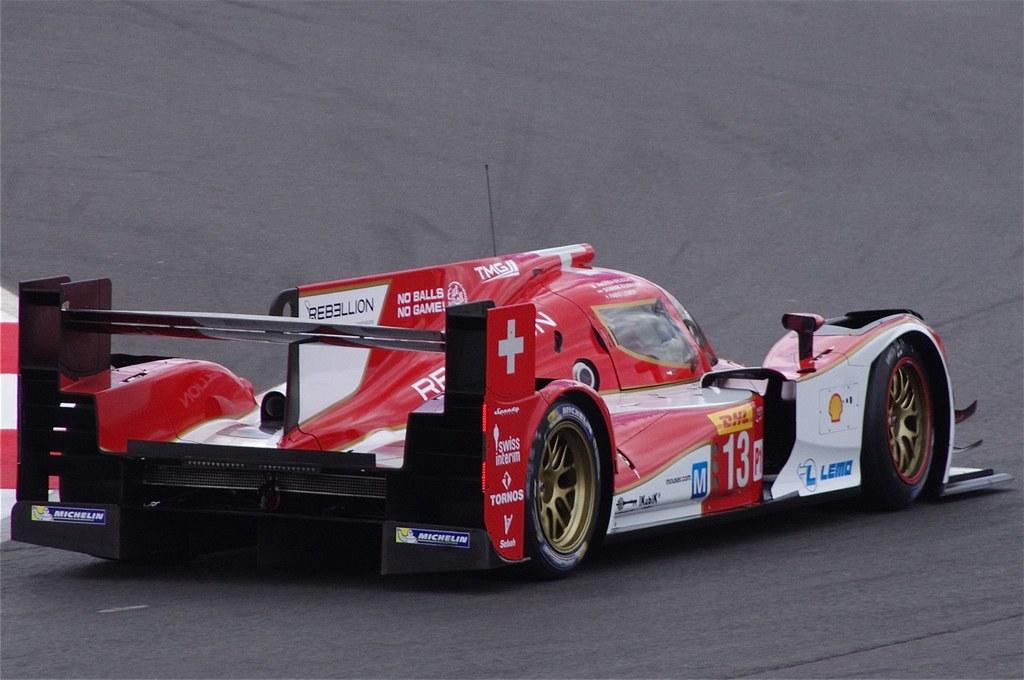Can you describe this image briefly? In this image we can see a vehicle on the road. 